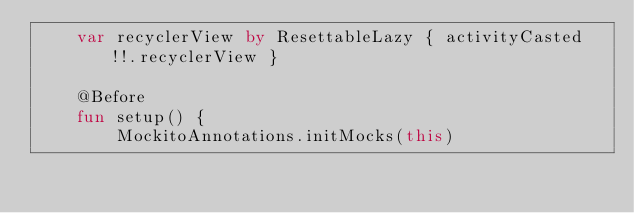<code> <loc_0><loc_0><loc_500><loc_500><_Kotlin_>    var recyclerView by ResettableLazy { activityCasted!!.recyclerView }

    @Before
    fun setup() {
        MockitoAnnotations.initMocks(this)</code> 